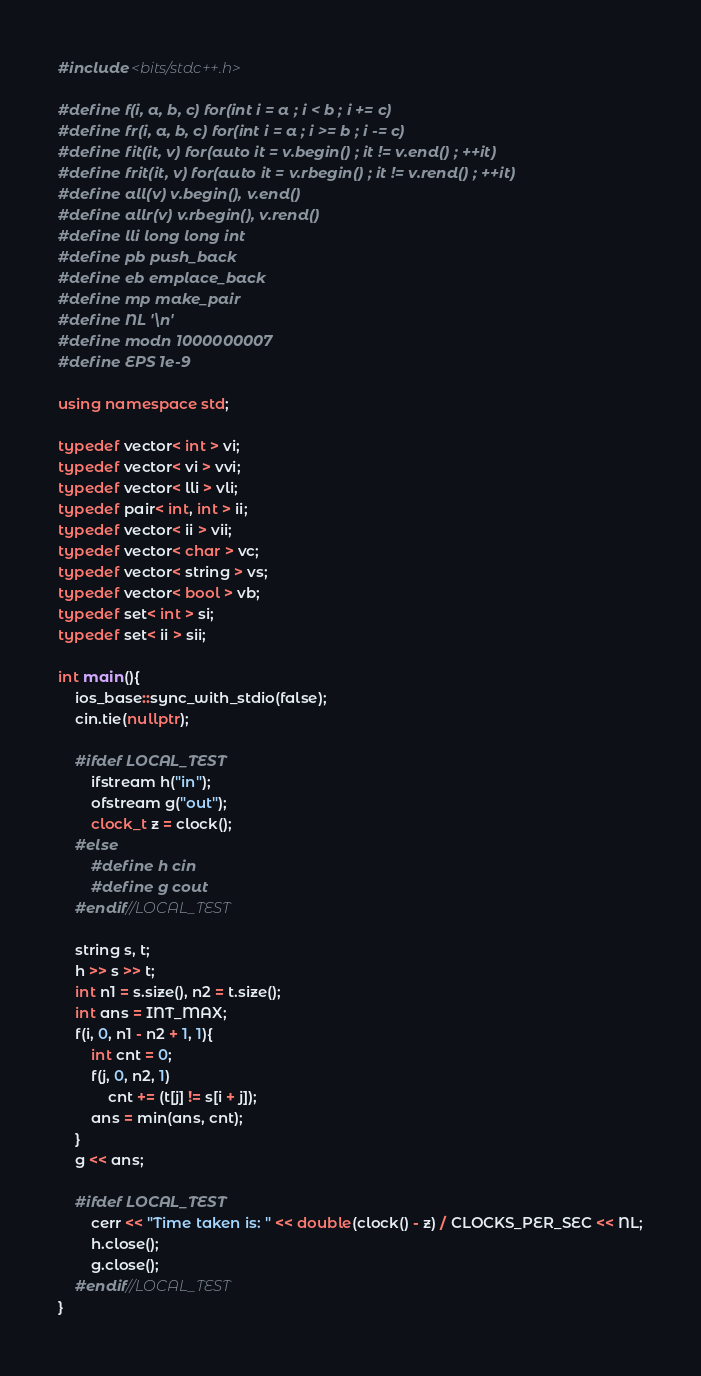Convert code to text. <code><loc_0><loc_0><loc_500><loc_500><_C++_>#include <bits/stdc++.h>

#define f(i, a, b, c) for(int i = a ; i < b ; i += c)
#define fr(i, a, b, c) for(int i = a ; i >= b ; i -= c)
#define fit(it, v) for(auto it = v.begin() ; it != v.end() ; ++it)
#define frit(it, v) for(auto it = v.rbegin() ; it != v.rend() ; ++it)
#define all(v) v.begin(), v.end()
#define allr(v) v.rbegin(), v.rend()
#define lli long long int
#define pb push_back
#define eb emplace_back
#define mp make_pair
#define NL '\n'
#define modn 1000000007
#define EPS 1e-9

using namespace std;

typedef vector< int > vi;
typedef vector< vi > vvi;
typedef vector< lli > vli;
typedef pair< int, int > ii;
typedef vector< ii > vii;
typedef vector< char > vc;
typedef vector< string > vs;
typedef vector< bool > vb;
typedef set< int > si;
typedef set< ii > sii;

int main(){
	ios_base::sync_with_stdio(false);
	cin.tie(nullptr);

	#ifdef LOCAL_TEST
		ifstream h("in");
		ofstream g("out");
		clock_t z = clock();
	#else
		#define h cin
		#define g cout
	#endif//LOCAL_TEST

	string s, t;
	h >> s >> t;
	int n1 = s.size(), n2 = t.size();
	int ans = INT_MAX;
	f(i, 0, n1 - n2 + 1, 1){
		int cnt = 0;
		f(j, 0, n2, 1)
			cnt += (t[j] != s[i + j]);
		ans = min(ans, cnt);
	}
	g << ans;

	#ifdef LOCAL_TEST
		cerr << "Time taken is: " << double(clock() - z) / CLOCKS_PER_SEC << NL;
		h.close();
		g.close();
	#endif//LOCAL_TEST
}
</code> 